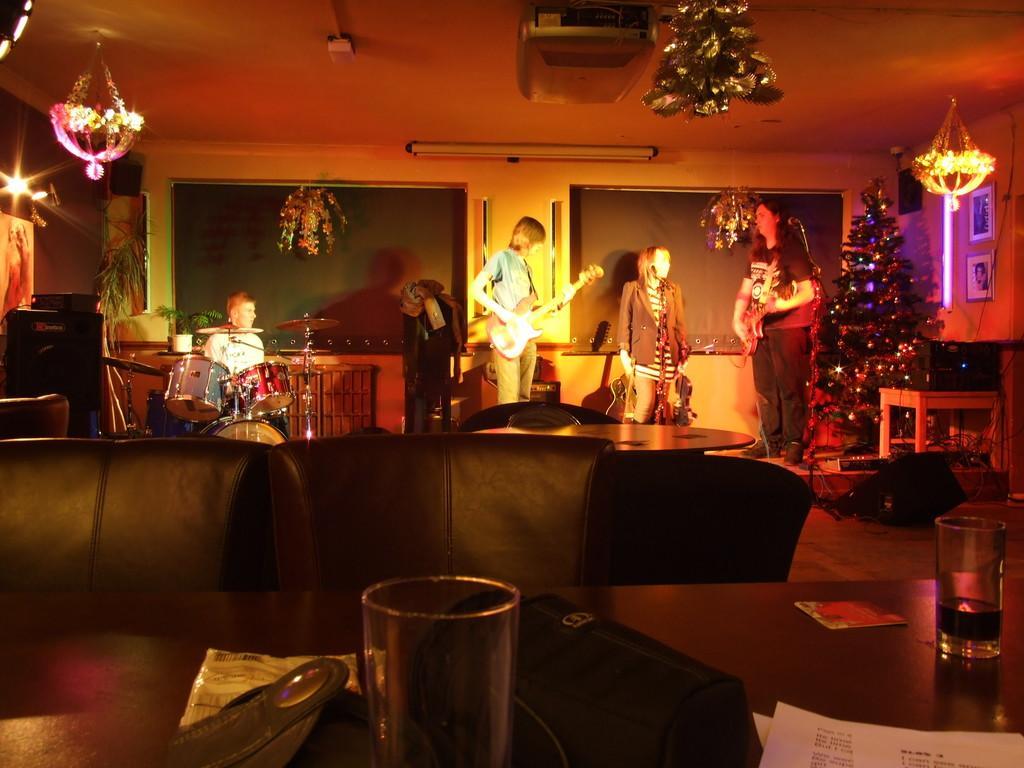Could you give a brief overview of what you see in this image? At the top we can see ceiling and lights and decorative things. This is a light and boards. We can see persons standing and playing musical instruments. This is a mike. We can see one person's sitting and playing drums. These are chairs near to the table and on the table we can see a paper, water glasses. We can see frames over a wall. 